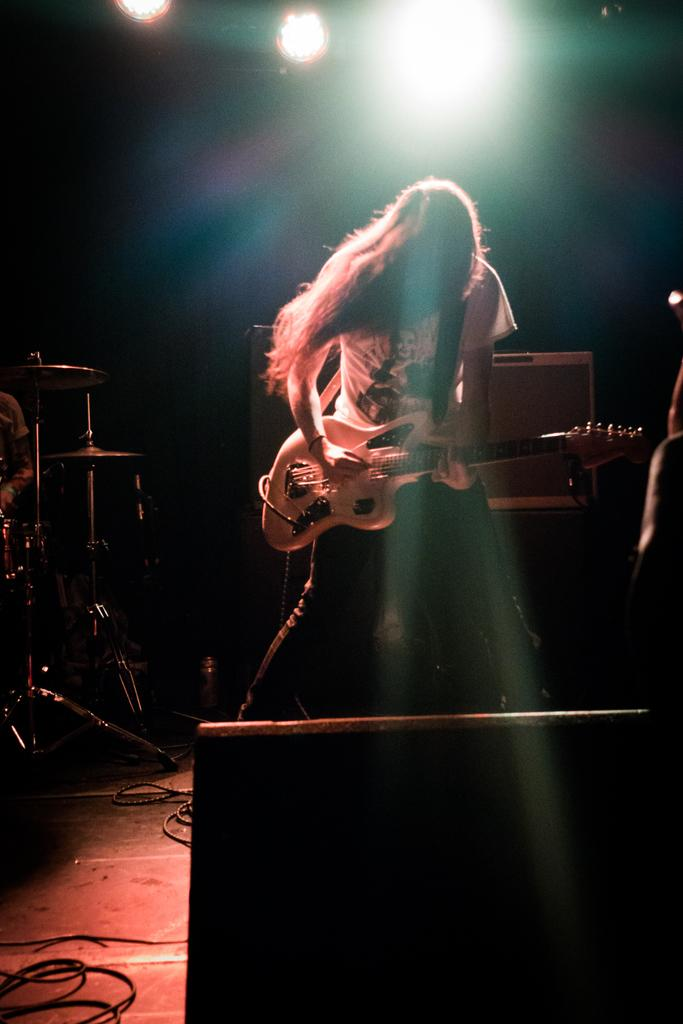What is the person in the image doing? There is a person playing the guitar in the image. What can be seen at the top of the image? There are lights visible at the top of the image. Where are the musical instruments located in the image? There are musical instruments on the left side of the image. What is the name of the person playing the guitar in the image? The provided facts do not include the name of the person playing the guitar, so we cannot answer this question. 